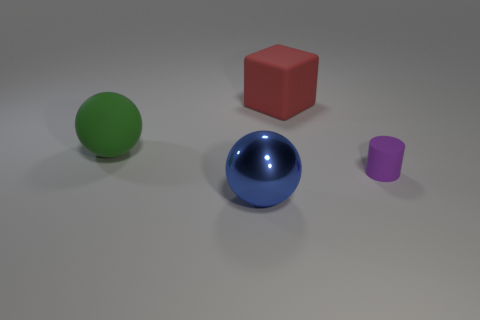Add 4 green rubber objects. How many objects exist? 8 Subtract all blocks. How many objects are left? 3 Add 2 large objects. How many large objects exist? 5 Subtract 0 cyan cylinders. How many objects are left? 4 Subtract all small blue shiny cylinders. Subtract all blue things. How many objects are left? 3 Add 3 metal things. How many metal things are left? 4 